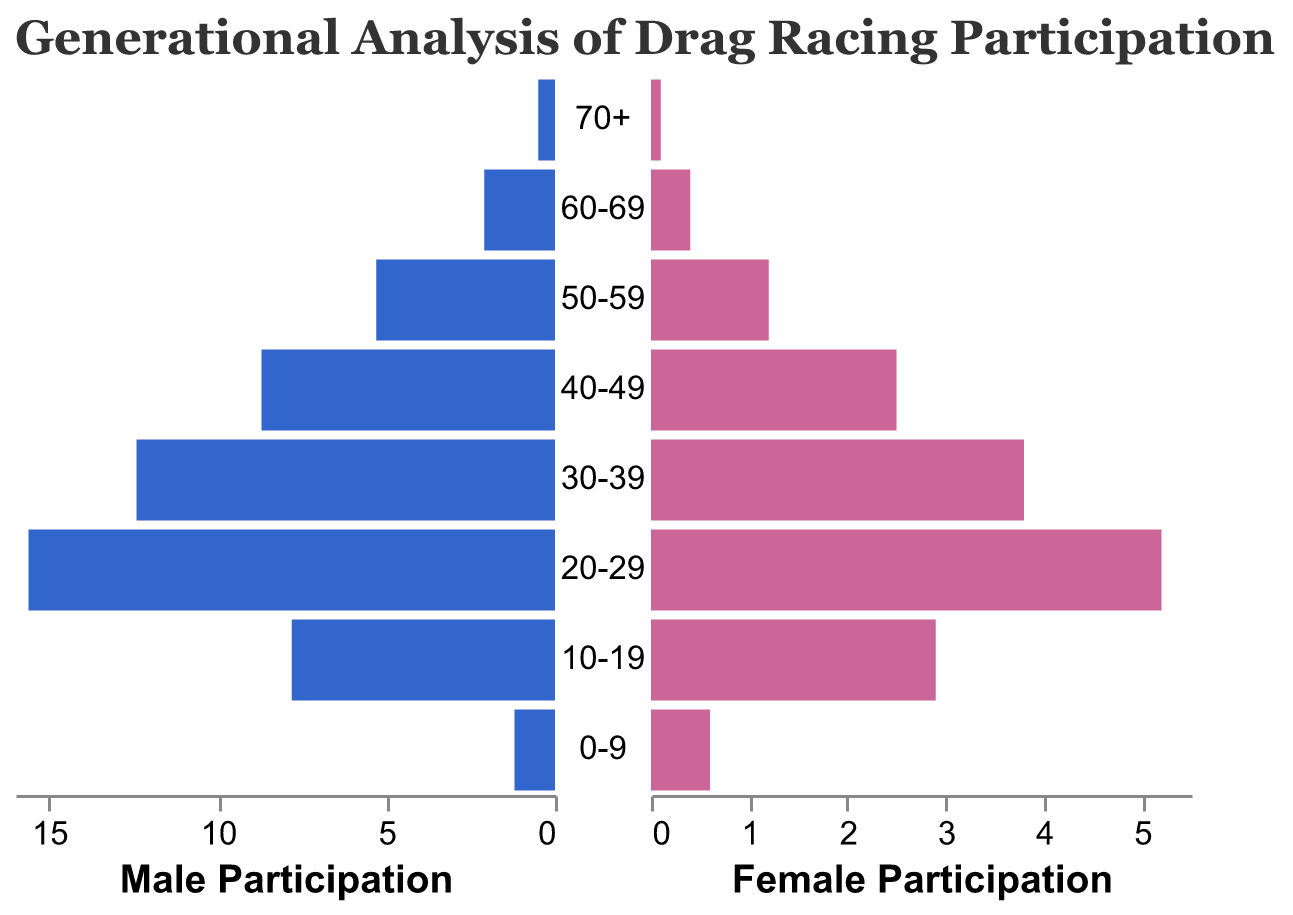What is the title of the figure? The title of the figure can be found at the top. It is in a larger font size to draw attention and provide context.
Answer: Generational Analysis of Drag Racing Participation How does the participation rate for males and females in the 70+ age group compare? The participation rate for both genders in the 70+ age group can be observed in the bars corresponding to that age group. The male bar is slightly longer than the female bar, indicating a higher participation rate for males.
Answer: Males participate more What age group has the highest male participation rate? By examining the length of the blue bars representing male participation across all age groups, the longest bar indicates the highest participation rate. The 20-29 age group has the longest male bar.
Answer: 20-29 What is the combined participation rate for males and females in the 50-59 age group? The combined participation rate is the sum of the male and female participation rates for the 50-59 age group. Checking the lengths of the bars, the rates are 5.3 (male) and 1.2 (female). Adding these gives 6.5.
Answer: 6.5 What is the difference in participation rates between males and females in the 20-29 age group? The difference can be found by subtracting the female participation rate from the male participation rate in the 20-29 age group. For this group, the rates are 15.6 (male) and 5.2 (female). The difference is 15.6 - 5.2.
Answer: 10.4 Which gender shows a greater overall increase in participation rate from age group 60-69 to 20-29? To determine the greater increase, calculate the differences in the participation rates for both genders between the 60-69 and 20-29 age groups. For males, the increase is 15.6 - 2.1, and for females, it is 5.2 - 0.4. Comparing these differences, males had a larger increase.
Answer: Males Which age group has the nearest male and female participation rates? To find the age group with the closest male and female participation rates, examine the differences for each age group. The smaller differences indicate closer rates. The age group 10-19 has the smallest difference with 7.8 (male) and 2.9 (female).
Answer: 10-19 Which age group shows the widest gap in participation rates between males and females? The age group with the widest gap can be found by identifying the largest difference between male and female participation rates across all age groups. Examining the data, the 20-29 age group shows the widest gap (15.6 male vs 5.2 female).
Answer: 20-29 What is the trend in female participation rates as age decreases? Observing the red bars for female participation from older to younger age groups, there is a general upward trend with shorter bars for older groups and longer bars for younger groups.
Answer: Increasing 